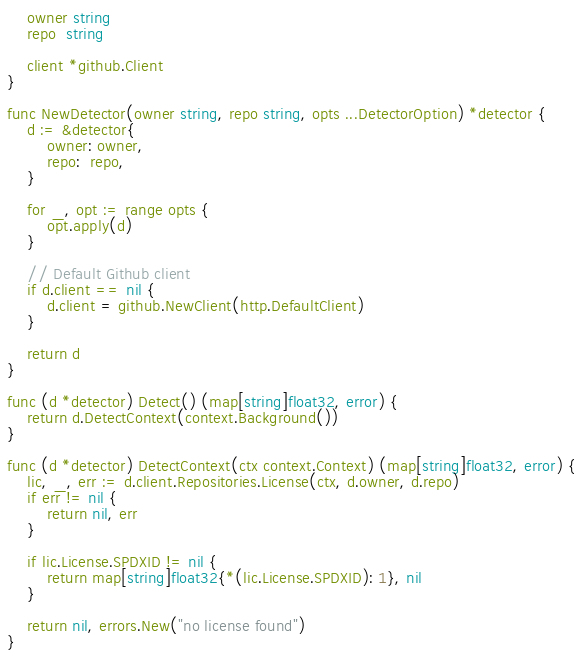<code> <loc_0><loc_0><loc_500><loc_500><_Go_>	owner string
	repo  string

	client *github.Client
}

func NewDetector(owner string, repo string, opts ...DetectorOption) *detector {
	d := &detector{
		owner: owner,
		repo:  repo,
	}

	for _, opt := range opts {
		opt.apply(d)
	}

	// Default Github client
	if d.client == nil {
		d.client = github.NewClient(http.DefaultClient)
	}

	return d
}

func (d *detector) Detect() (map[string]float32, error) {
	return d.DetectContext(context.Background())
}

func (d *detector) DetectContext(ctx context.Context) (map[string]float32, error) {
	lic, _, err := d.client.Repositories.License(ctx, d.owner, d.repo)
	if err != nil {
		return nil, err
	}

	if lic.License.SPDXID != nil {
		return map[string]float32{*(lic.License.SPDXID): 1}, nil
	}

	return nil, errors.New("no license found")
}
</code> 